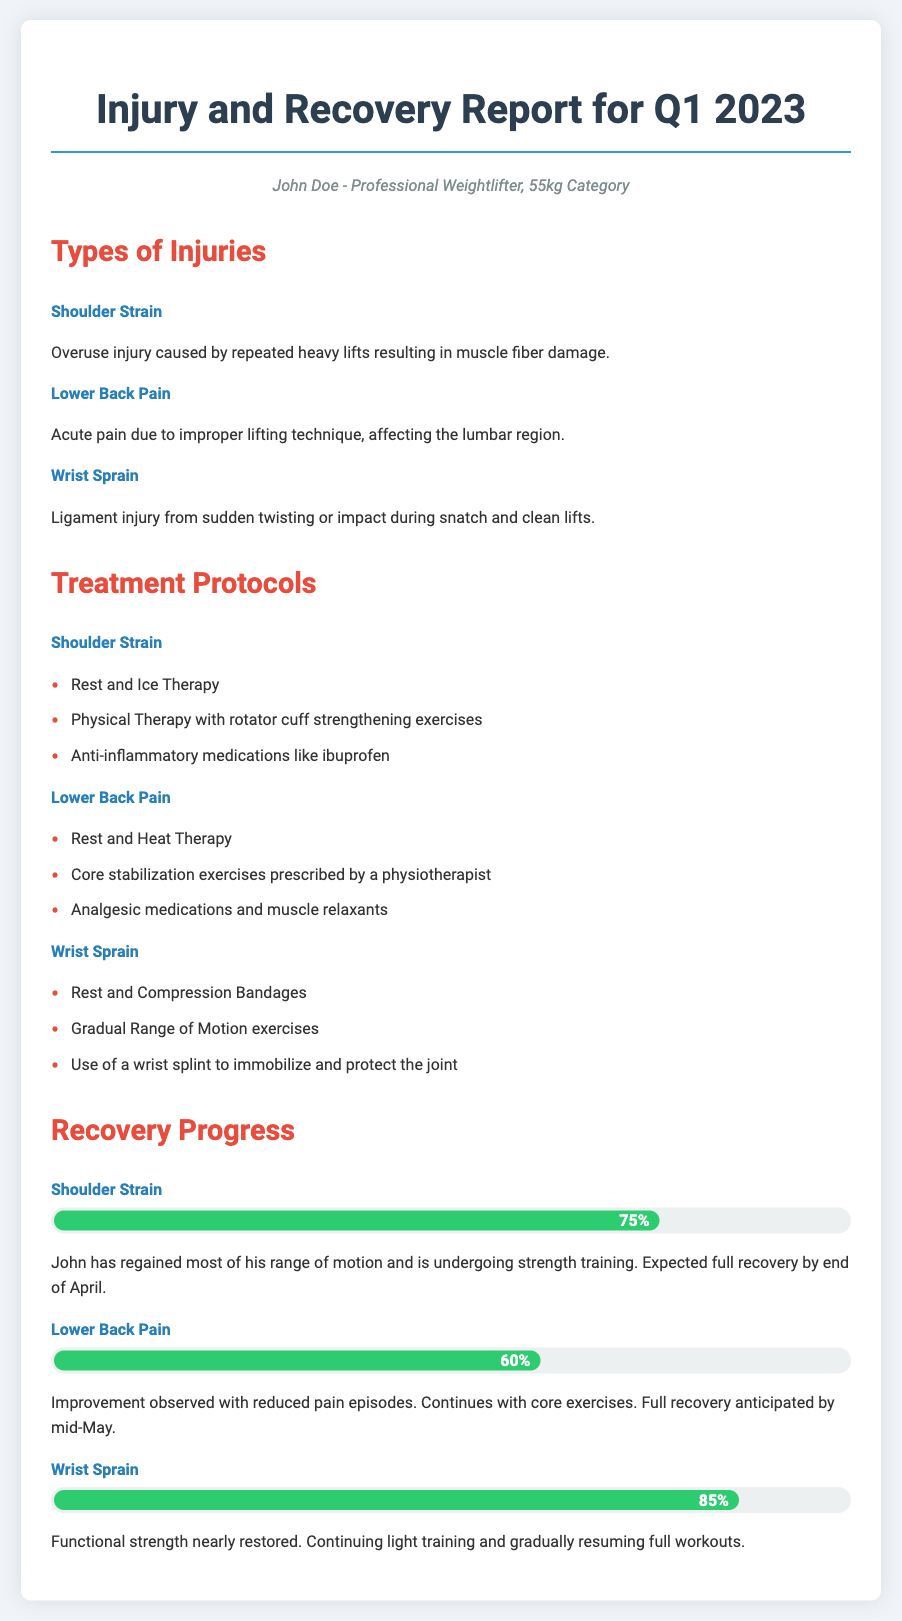What are the types of injuries reported? The document lists three main injuries: Shoulder Strain, Lower Back Pain, and Wrist Sprain.
Answer: Shoulder Strain, Lower Back Pain, Wrist Sprain What percentage of recovery is noted for the Shoulder Strain? The document specifies that the recovery progress for Shoulder Strain is at 75%.
Answer: 75% What treatment is recommended for Lower Back Pain? The treatment includes Rest and Heat Therapy, core stabilization exercises, and analgesic medications.
Answer: Rest and Heat Therapy What is the expected full recovery date for Wrist Sprain? The document indicates that the functional strength is nearly restored with full workouts being gradually resumed, but no specific full recovery date is provided.
Answer: Not specified What percentage completion of recovery is indicated for the Lower Back Pain? The document states that the recovery progress for Lower Back Pain is currently 60%.
Answer: 60% Which injury has the highest recovery progress as of the report? The document shows that the Wrist Sprain has the highest recovery progress at 85%.
Answer: Wrist Sprain What specific physical therapy is recommended for Shoulder Strain? The document mentions physical therapy focusing on rotator cuff strengthening exercises as part of the treatment.
Answer: Rotator cuff strengthening exercises What is John Doe's competitive category? The persona identifies John Doe as a professional weightlifter in the 55kg category.
Answer: 55kg category What is the anticipated full recovery date for the Shoulder Strain? The document states that full recovery for the Shoulder Strain is expected by the end of April.
Answer: End of April 